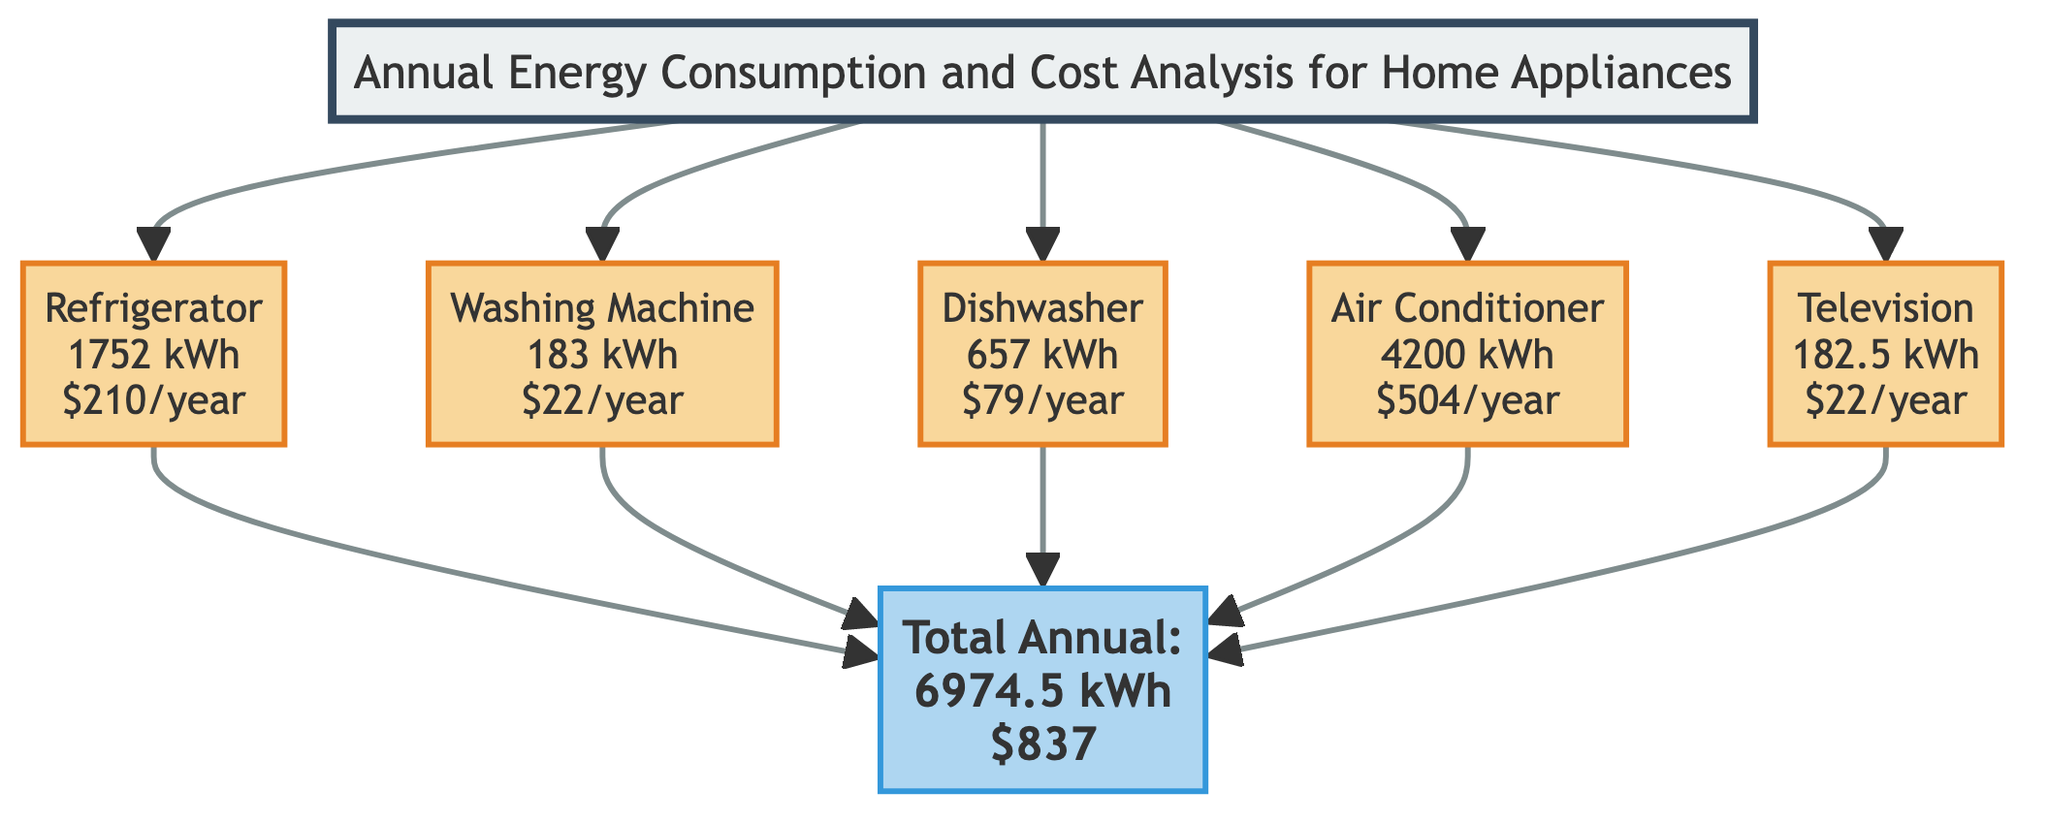What is the annual cost of the Refrigerator? The diagram lists the Refrigerator with an annual cost of $210. This information is explicitly shown in the block representing the Refrigerator.
Answer: $210 What is the total annual consumption of all appliances? The summary block indicates the total annual consumption as 6974.5 kWh, which is derived from adding the individual annual consumptions of all appliances listed.
Answer: 6974.5 kWh Which appliance has the highest annual cost? By comparing the annual costs of each appliance, the Air Conditioner has the highest annual cost of $504 among all appliances listed in the diagram.
Answer: Air Conditioner How many appliances are analyzed in the diagram? The diagram features a total of five distinct appliances: Refrigerator, Washing Machine, Dishwasher, Air Conditioner, and Television. Thus, it counts each individually listed appliance block.
Answer: 5 What is the annual cost of the Television? The Television block indicates an annual cost of $22. This detail is explicitly provided in its respective block.
Answer: $22 What would be the total annual cost if you only include the Dishwasher and Washing Machine? The annual cost of the Dishwasher is $79, and for the Washing Machine, it is $22. Adding these two amounts results in a total cost of $101 for these two appliances.
Answer: $101 What is the power consumption of the Air Conditioner? The block for the Air Conditioner states that its power consumption is 3500 W, providing this specific value without needing to reference other information.
Answer: 3500 W How many hours per day is the Washing Machine used? The Washing Machine block specifies a usage of 1 hour per day, directly stating this figure in the block for clarity.
Answer: 1 hour What is the total annual cost of all appliances? The summary block portrays that the total annual cost for all appliances combined is $837, showing the cumulative financial expenditure for running them.
Answer: $837 